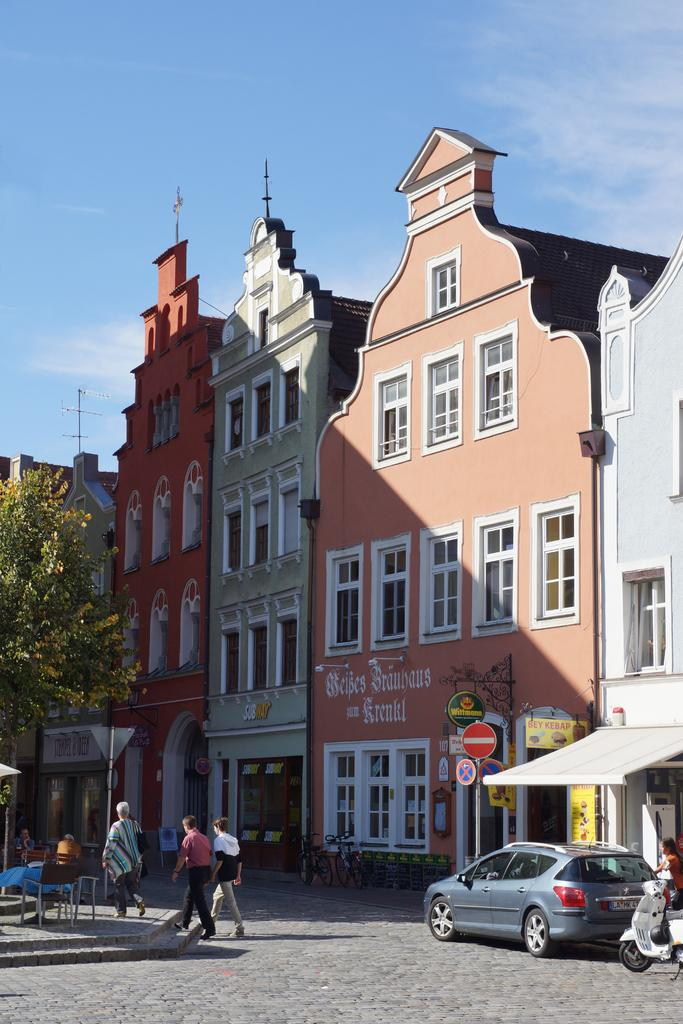What are the people in the image doing? The people in the image are walking. What else can be seen on the road besides people? Vehicles are present on the road. What type of furniture is visible in the image? There are chairs and a table in the image. What type of structures can be seen in the image? Buildings are visible in the image. What are the boards on poles used for? The boards on poles are likely used for advertising or displaying information. What can be seen illuminating the scene in the image? Lights are visible in the image. What type of plant is present in the image? There is a tree in the image. What is visible in the background of the image? The sky is visible in the background. What type of lace is used to decorate the buildings in the image? There is no mention of lace or any decorative elements on the buildings in the image. What type of education is being provided in the image? There is no indication of any educational activity or institution in the image. 